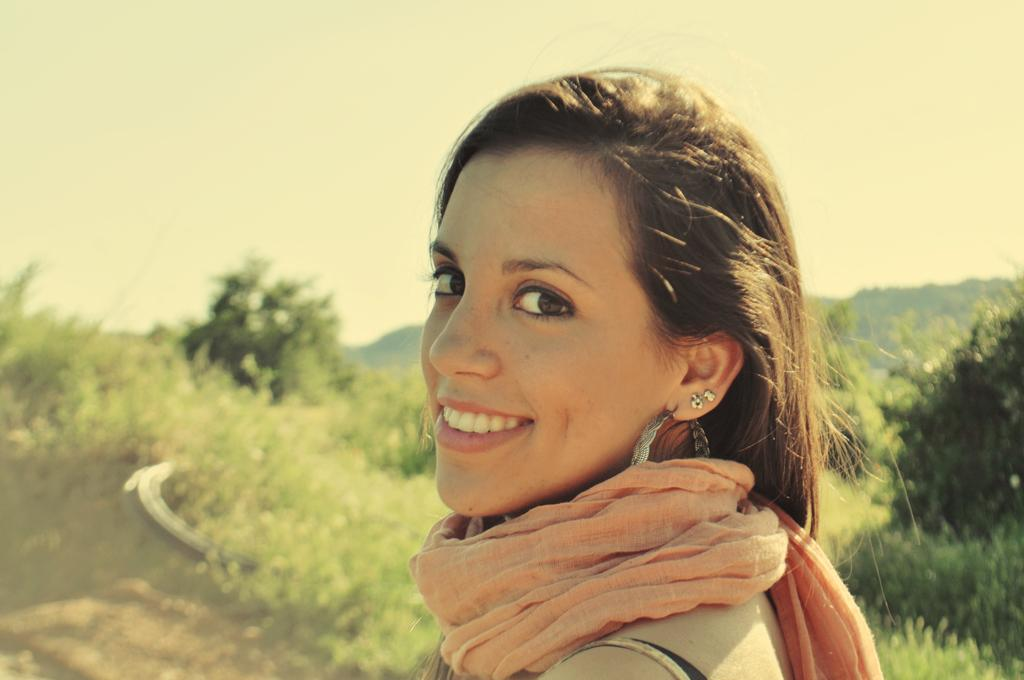What is the main subject of the image? The main subject of the image is a woman standing in the middle. What is the woman doing in the image? The woman is smiling in the image. What can be seen in the background of the image? There are trees behind the woman in the image. What is visible at the top of the image? The sky is visible at the top of the image. Where is the market located in the image? There is no market present in the image. What type of grass is growing around the woman in the image? There is no grass visible in the image; only trees are mentioned in the background. 